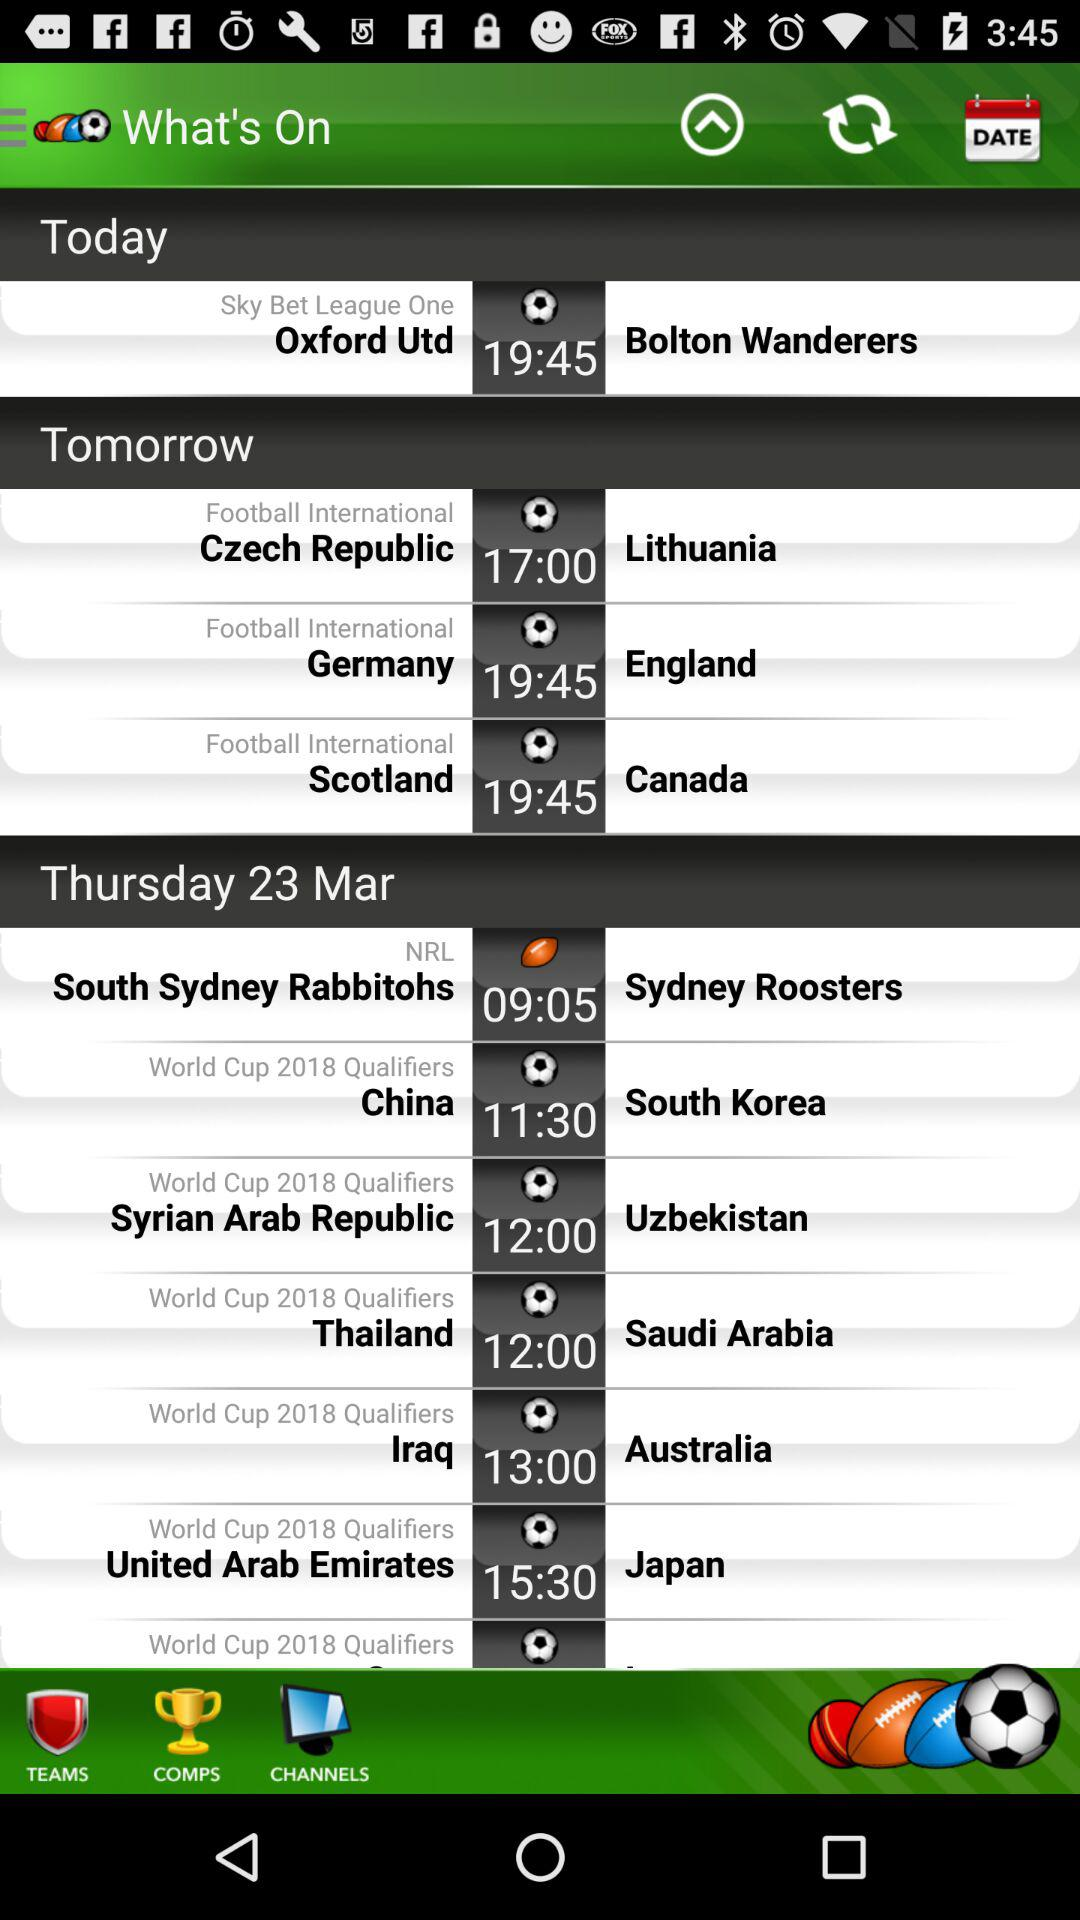What is the time for the "South Sydney Rabbitohs"? The time for the "South Sydney Rabbitohs" is 09:05. 